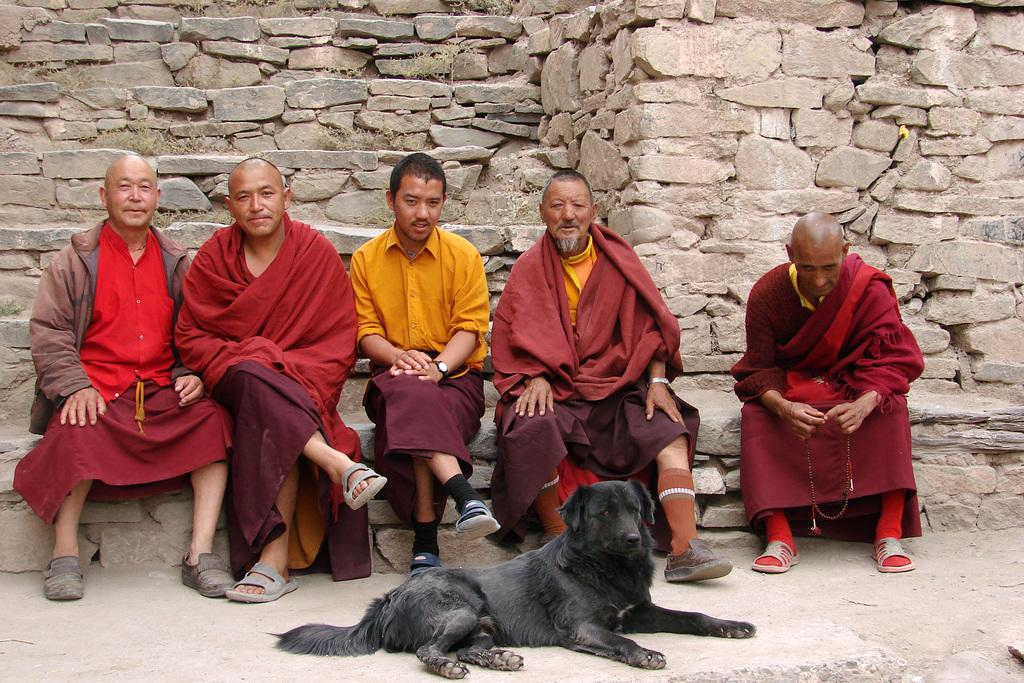How many people are in the image? There is a group of people in the image, but the exact number is not specified. What are the people in the image doing? The people are seated in the image. What animal is present in the image? There is a dog in front of the people in the image. What can be seen in the background of the image? Rocks are visible in the background of the image. What type of pencil can be seen on the edge of the image? There is no pencil present in the image, and therefore no such object can be seen on the edge. 